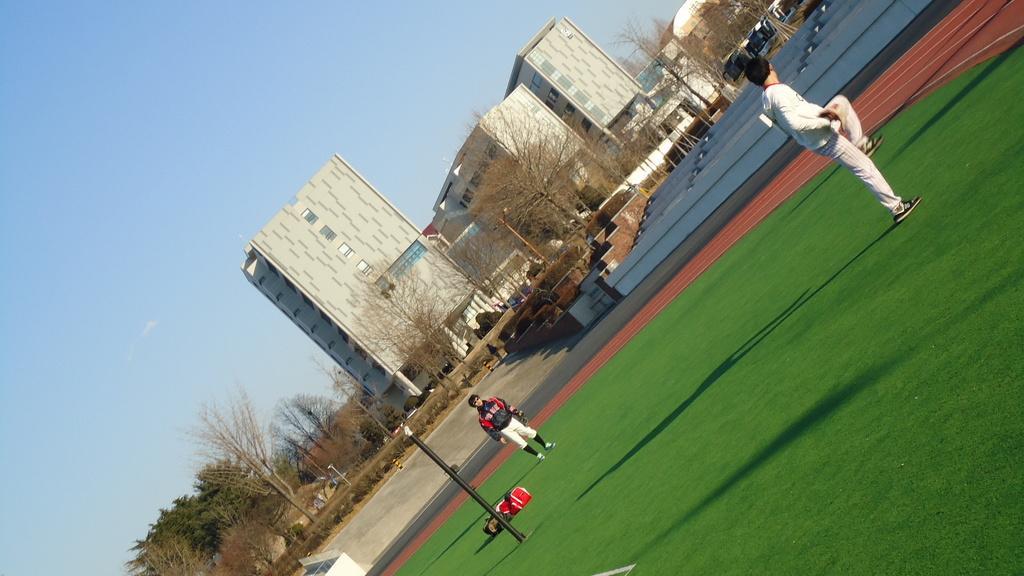Could you give a brief overview of what you see in this image? In this image we can see sky, buildings, trees, poles, stairs and persons standing on the ground. 